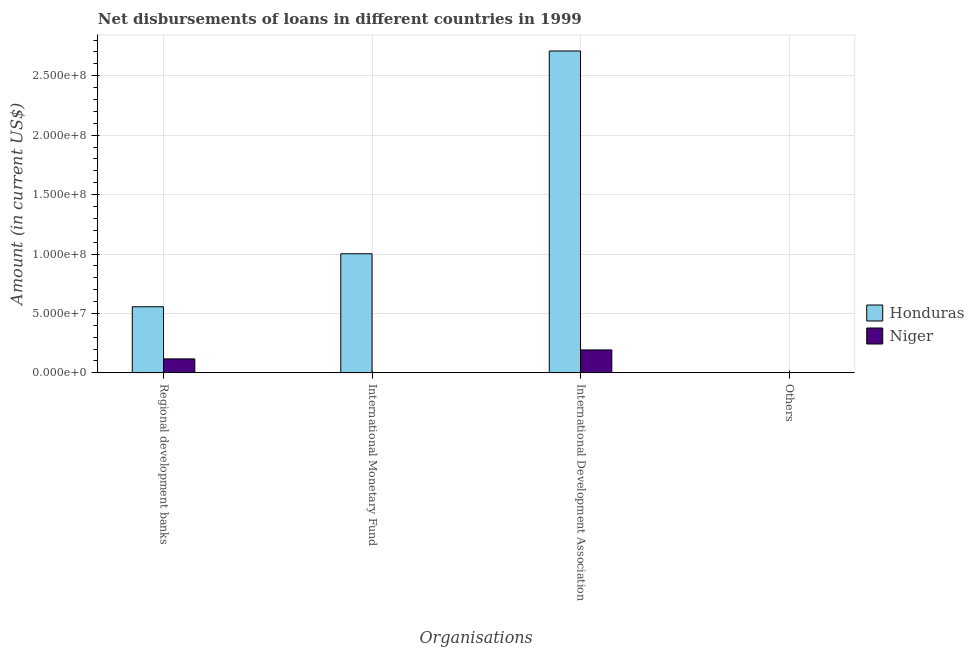How many bars are there on the 3rd tick from the left?
Your response must be concise. 2. How many bars are there on the 3rd tick from the right?
Your answer should be very brief. 1. What is the label of the 4th group of bars from the left?
Ensure brevity in your answer.  Others. What is the amount of loan disimbursed by regional development banks in Honduras?
Offer a very short reply. 5.56e+07. Across all countries, what is the maximum amount of loan disimbursed by international monetary fund?
Ensure brevity in your answer.  1.00e+08. Across all countries, what is the minimum amount of loan disimbursed by international development association?
Offer a terse response. 1.93e+07. In which country was the amount of loan disimbursed by regional development banks maximum?
Your answer should be compact. Honduras. What is the total amount of loan disimbursed by international monetary fund in the graph?
Offer a very short reply. 1.00e+08. What is the difference between the amount of loan disimbursed by regional development banks in Niger and that in Honduras?
Keep it short and to the point. -4.39e+07. What is the difference between the amount of loan disimbursed by international development association in Niger and the amount of loan disimbursed by regional development banks in Honduras?
Your answer should be very brief. -3.63e+07. What is the difference between the amount of loan disimbursed by international monetary fund and amount of loan disimbursed by regional development banks in Honduras?
Provide a short and direct response. 4.46e+07. What is the ratio of the amount of loan disimbursed by international development association in Honduras to that in Niger?
Offer a very short reply. 14.03. Is the amount of loan disimbursed by international development association in Niger less than that in Honduras?
Give a very brief answer. Yes. What is the difference between the highest and the second highest amount of loan disimbursed by regional development banks?
Your response must be concise. 4.39e+07. What is the difference between the highest and the lowest amount of loan disimbursed by international development association?
Provide a short and direct response. 2.52e+08. In how many countries, is the amount of loan disimbursed by other organisations greater than the average amount of loan disimbursed by other organisations taken over all countries?
Make the answer very short. 0. Is it the case that in every country, the sum of the amount of loan disimbursed by regional development banks and amount of loan disimbursed by international monetary fund is greater than the amount of loan disimbursed by international development association?
Offer a terse response. No. How many bars are there?
Make the answer very short. 5. Are the values on the major ticks of Y-axis written in scientific E-notation?
Offer a very short reply. Yes. Does the graph contain grids?
Your response must be concise. Yes. Where does the legend appear in the graph?
Offer a terse response. Center right. How many legend labels are there?
Your answer should be very brief. 2. How are the legend labels stacked?
Your response must be concise. Vertical. What is the title of the graph?
Offer a terse response. Net disbursements of loans in different countries in 1999. What is the label or title of the X-axis?
Give a very brief answer. Organisations. What is the label or title of the Y-axis?
Provide a succinct answer. Amount (in current US$). What is the Amount (in current US$) of Honduras in Regional development banks?
Offer a terse response. 5.56e+07. What is the Amount (in current US$) in Niger in Regional development banks?
Your response must be concise. 1.17e+07. What is the Amount (in current US$) of Honduras in International Monetary Fund?
Give a very brief answer. 1.00e+08. What is the Amount (in current US$) of Honduras in International Development Association?
Give a very brief answer. 2.71e+08. What is the Amount (in current US$) in Niger in International Development Association?
Provide a short and direct response. 1.93e+07. What is the Amount (in current US$) of Honduras in Others?
Your answer should be compact. 0. What is the Amount (in current US$) in Niger in Others?
Keep it short and to the point. 0. Across all Organisations, what is the maximum Amount (in current US$) of Honduras?
Give a very brief answer. 2.71e+08. Across all Organisations, what is the maximum Amount (in current US$) in Niger?
Your answer should be very brief. 1.93e+07. Across all Organisations, what is the minimum Amount (in current US$) of Niger?
Offer a terse response. 0. What is the total Amount (in current US$) in Honduras in the graph?
Make the answer very short. 4.27e+08. What is the total Amount (in current US$) in Niger in the graph?
Provide a short and direct response. 3.10e+07. What is the difference between the Amount (in current US$) in Honduras in Regional development banks and that in International Monetary Fund?
Ensure brevity in your answer.  -4.46e+07. What is the difference between the Amount (in current US$) of Honduras in Regional development banks and that in International Development Association?
Your response must be concise. -2.15e+08. What is the difference between the Amount (in current US$) in Niger in Regional development banks and that in International Development Association?
Ensure brevity in your answer.  -7.55e+06. What is the difference between the Amount (in current US$) in Honduras in International Monetary Fund and that in International Development Association?
Your answer should be very brief. -1.71e+08. What is the difference between the Amount (in current US$) in Honduras in Regional development banks and the Amount (in current US$) in Niger in International Development Association?
Provide a short and direct response. 3.63e+07. What is the difference between the Amount (in current US$) in Honduras in International Monetary Fund and the Amount (in current US$) in Niger in International Development Association?
Keep it short and to the point. 8.09e+07. What is the average Amount (in current US$) in Honduras per Organisations?
Provide a short and direct response. 1.07e+08. What is the average Amount (in current US$) in Niger per Organisations?
Provide a succinct answer. 7.76e+06. What is the difference between the Amount (in current US$) of Honduras and Amount (in current US$) of Niger in Regional development banks?
Offer a terse response. 4.39e+07. What is the difference between the Amount (in current US$) of Honduras and Amount (in current US$) of Niger in International Development Association?
Keep it short and to the point. 2.52e+08. What is the ratio of the Amount (in current US$) of Honduras in Regional development banks to that in International Monetary Fund?
Your answer should be very brief. 0.56. What is the ratio of the Amount (in current US$) in Honduras in Regional development banks to that in International Development Association?
Offer a very short reply. 0.21. What is the ratio of the Amount (in current US$) in Niger in Regional development banks to that in International Development Association?
Provide a short and direct response. 0.61. What is the ratio of the Amount (in current US$) of Honduras in International Monetary Fund to that in International Development Association?
Provide a short and direct response. 0.37. What is the difference between the highest and the second highest Amount (in current US$) in Honduras?
Give a very brief answer. 1.71e+08. What is the difference between the highest and the lowest Amount (in current US$) of Honduras?
Give a very brief answer. 2.71e+08. What is the difference between the highest and the lowest Amount (in current US$) in Niger?
Offer a very short reply. 1.93e+07. 